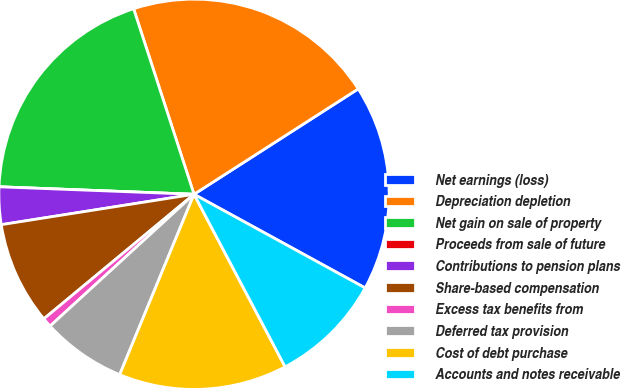<chart> <loc_0><loc_0><loc_500><loc_500><pie_chart><fcel>Net earnings (loss)<fcel>Depreciation depletion<fcel>Net gain on sale of property<fcel>Proceeds from sale of future<fcel>Contributions to pension plans<fcel>Share-based compensation<fcel>Excess tax benefits from<fcel>Deferred tax provision<fcel>Cost of debt purchase<fcel>Accounts and notes receivable<nl><fcel>17.05%<fcel>20.93%<fcel>19.38%<fcel>0.0%<fcel>3.1%<fcel>8.53%<fcel>0.78%<fcel>6.98%<fcel>13.95%<fcel>9.3%<nl></chart> 